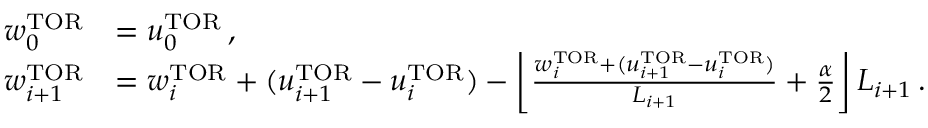<formula> <loc_0><loc_0><loc_500><loc_500>\begin{array} { r l } { w _ { 0 } ^ { T O R } } & { = u _ { 0 } ^ { T O R } \, , } \\ { w _ { i + 1 } ^ { T O R } } & { = w _ { i } ^ { T O R } + ( u _ { i + 1 } ^ { T O R } - u _ { i } ^ { T O R } ) - \left \lfloor \frac { w _ { i } ^ { T O R } + ( u _ { i + 1 } ^ { T O R } - u _ { i } ^ { T O R } ) } { L _ { i + 1 } } + \frac { \alpha } { 2 } \right \rfloor L _ { i + 1 } \, . } \end{array}</formula> 